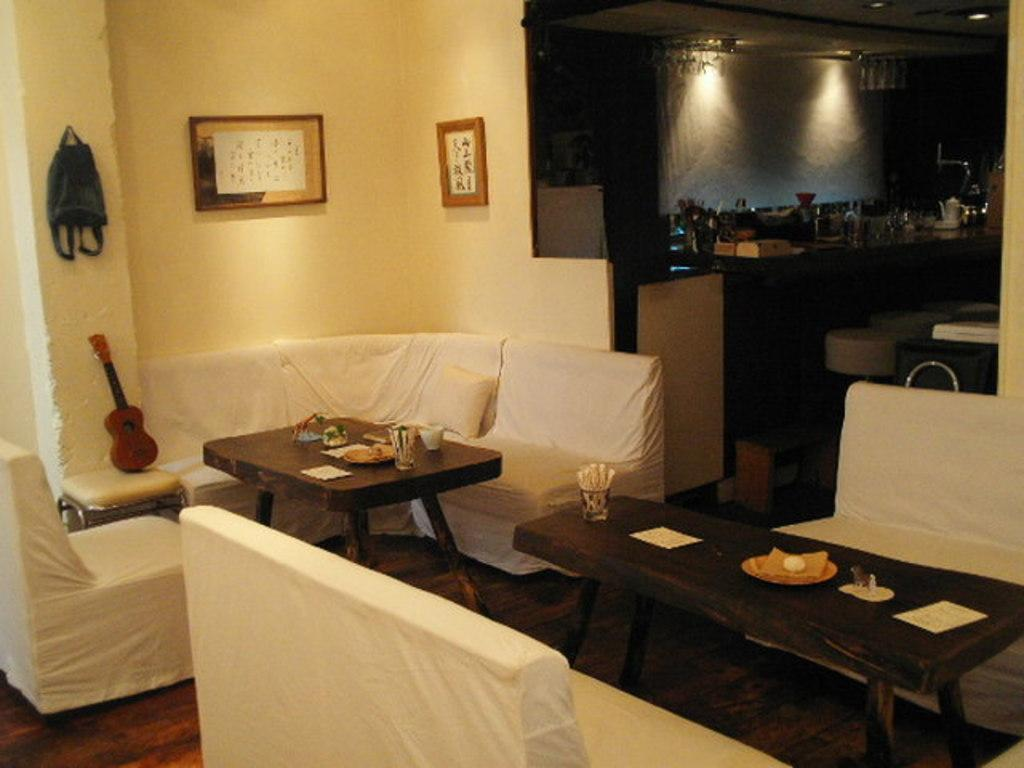What type of furniture is present in the image? There are chairs and tables in the image. What can be seen on the wall in the image? There is a wall with photo frames in the image. What is on the platform in the image? There are objects on the platform in the image. What type of flooring is visible at the bottom of the image? There is wooden flooring at the bottom of the image. How many bones are visible on the floor in the image? There are no bones visible on the floor in the image. What type of toys can be seen on the platform in the image? There are no toys present in the image; only objects are visible on the platform. 